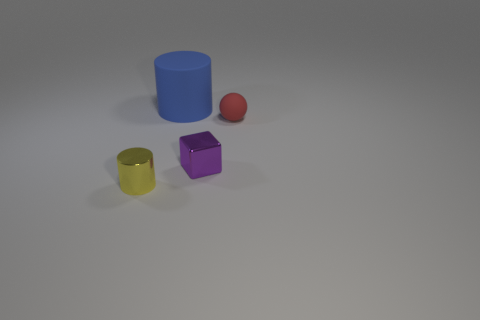Add 1 tiny yellow metallic cylinders. How many objects exist? 5 Add 3 tiny brown shiny cylinders. How many tiny brown shiny cylinders exist? 3 Subtract 0 green cylinders. How many objects are left? 4 Subtract all brown spheres. Subtract all small yellow cylinders. How many objects are left? 3 Add 2 small yellow shiny objects. How many small yellow shiny objects are left? 3 